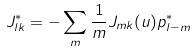Convert formula to latex. <formula><loc_0><loc_0><loc_500><loc_500>J ^ { * } _ { l k } = - \sum _ { m } \frac { 1 } { m } J _ { m k } ( u ) p ^ { * } _ { l - m }</formula> 